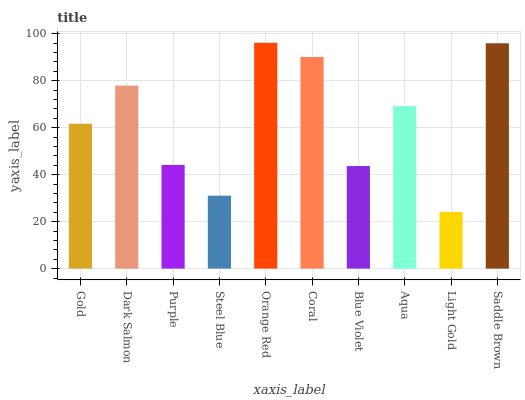Is Light Gold the minimum?
Answer yes or no. Yes. Is Orange Red the maximum?
Answer yes or no. Yes. Is Dark Salmon the minimum?
Answer yes or no. No. Is Dark Salmon the maximum?
Answer yes or no. No. Is Dark Salmon greater than Gold?
Answer yes or no. Yes. Is Gold less than Dark Salmon?
Answer yes or no. Yes. Is Gold greater than Dark Salmon?
Answer yes or no. No. Is Dark Salmon less than Gold?
Answer yes or no. No. Is Aqua the high median?
Answer yes or no. Yes. Is Gold the low median?
Answer yes or no. Yes. Is Purple the high median?
Answer yes or no. No. Is Light Gold the low median?
Answer yes or no. No. 